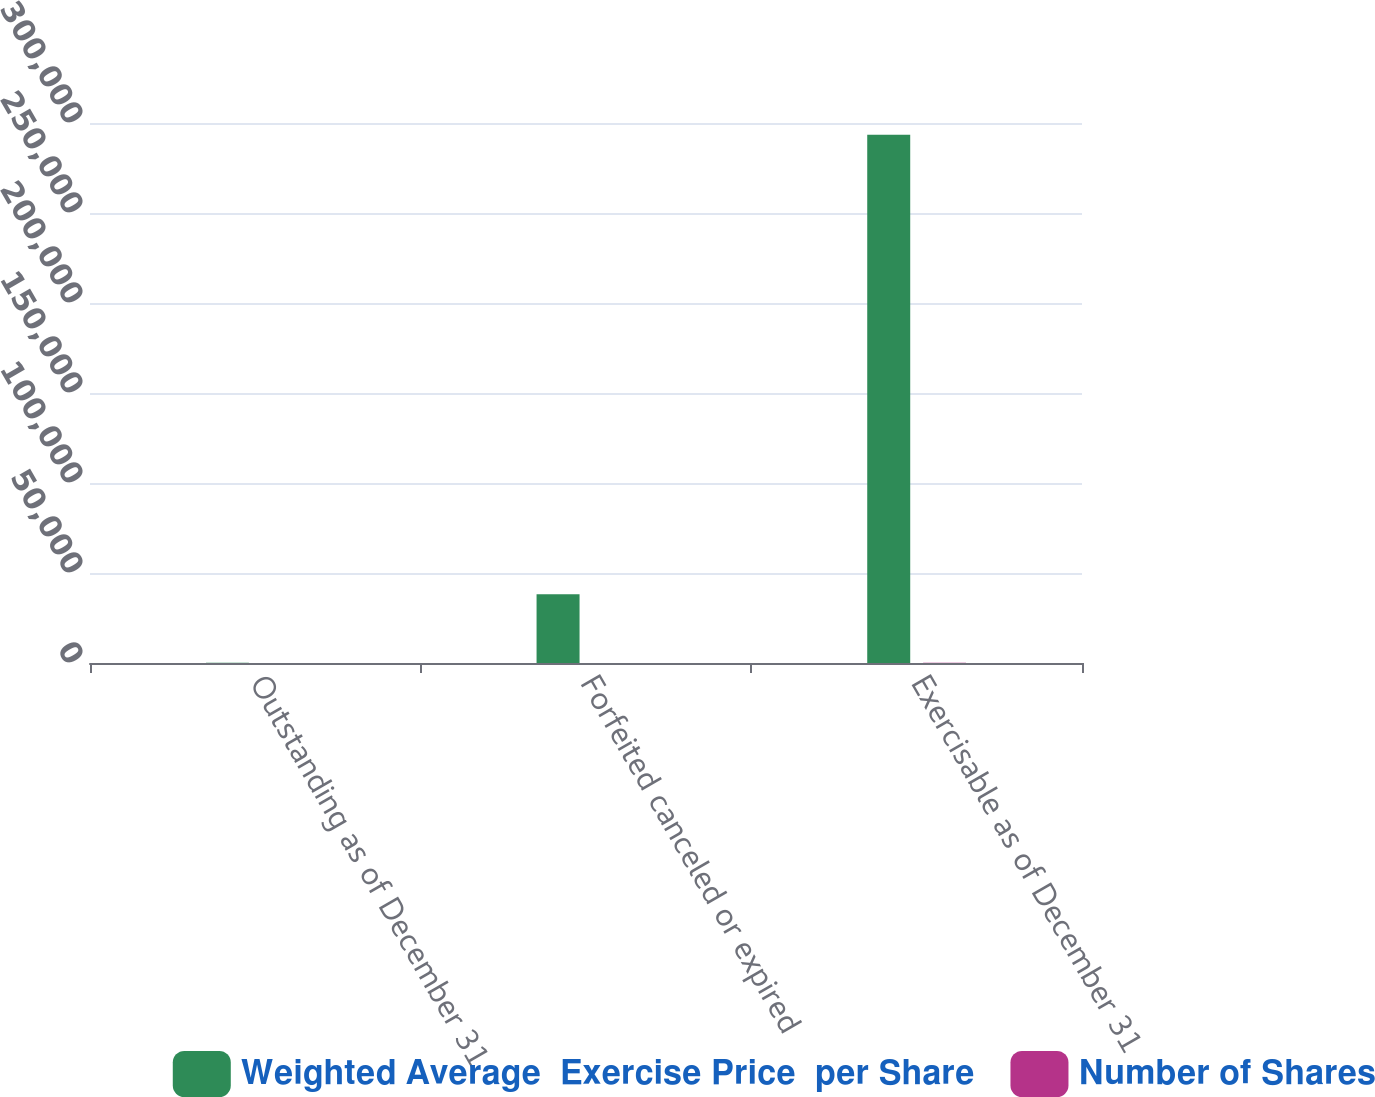Convert chart. <chart><loc_0><loc_0><loc_500><loc_500><stacked_bar_chart><ecel><fcel>Outstanding as of December 31<fcel>Forfeited canceled or expired<fcel>Exercisable as of December 31<nl><fcel>Weighted Average  Exercise Price  per Share<fcel>73.47<fcel>38227<fcel>293517<nl><fcel>Number of Shares<fcel>66.83<fcel>69.03<fcel>70.57<nl></chart> 